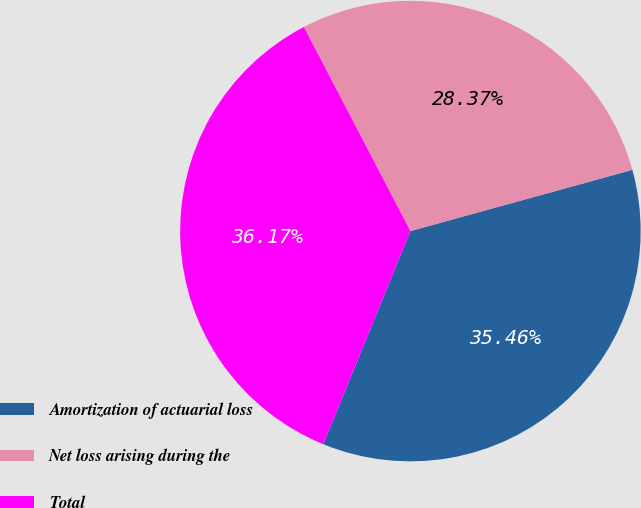Convert chart to OTSL. <chart><loc_0><loc_0><loc_500><loc_500><pie_chart><fcel>Amortization of actuarial loss<fcel>Net loss arising during the<fcel>Total<nl><fcel>35.46%<fcel>28.37%<fcel>36.17%<nl></chart> 